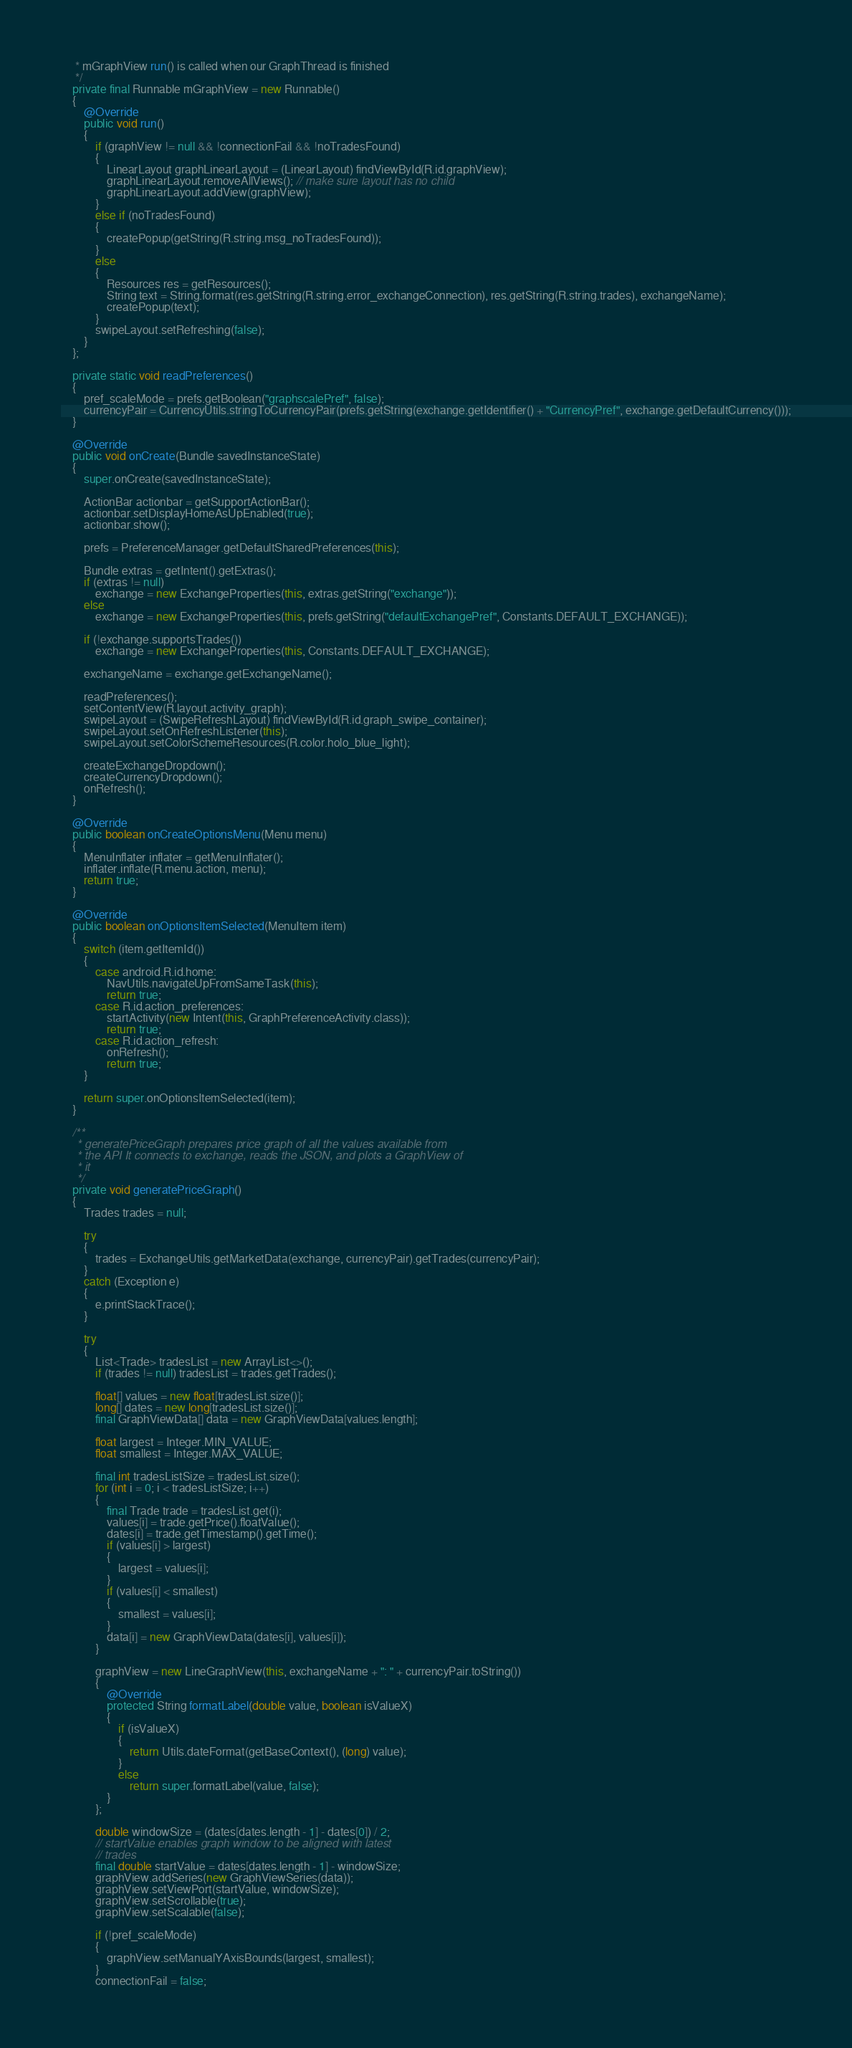<code> <loc_0><loc_0><loc_500><loc_500><_Java_>     * mGraphView run() is called when our GraphThread is finished
     */
    private final Runnable mGraphView = new Runnable()
    {
        @Override
        public void run()
        {
            if (graphView != null && !connectionFail && !noTradesFound)
            {
                LinearLayout graphLinearLayout = (LinearLayout) findViewById(R.id.graphView);
                graphLinearLayout.removeAllViews(); // make sure layout has no child
                graphLinearLayout.addView(graphView);
            }
            else if (noTradesFound)
            {
                createPopup(getString(R.string.msg_noTradesFound));
            }
            else
            {
                Resources res = getResources();
                String text = String.format(res.getString(R.string.error_exchangeConnection), res.getString(R.string.trades), exchangeName);
                createPopup(text);
            }
            swipeLayout.setRefreshing(false);
        }
    };

    private static void readPreferences()
    {
        pref_scaleMode = prefs.getBoolean("graphscalePref", false);
        currencyPair = CurrencyUtils.stringToCurrencyPair(prefs.getString(exchange.getIdentifier() + "CurrencyPref", exchange.getDefaultCurrency()));
    }

    @Override
    public void onCreate(Bundle savedInstanceState)
    {
        super.onCreate(savedInstanceState);

        ActionBar actionbar = getSupportActionBar();
        actionbar.setDisplayHomeAsUpEnabled(true);
        actionbar.show();

        prefs = PreferenceManager.getDefaultSharedPreferences(this);

        Bundle extras = getIntent().getExtras();
        if (extras != null)
            exchange = new ExchangeProperties(this, extras.getString("exchange"));
        else
            exchange = new ExchangeProperties(this, prefs.getString("defaultExchangePref", Constants.DEFAULT_EXCHANGE));

        if (!exchange.supportsTrades())
            exchange = new ExchangeProperties(this, Constants.DEFAULT_EXCHANGE);

        exchangeName = exchange.getExchangeName();

        readPreferences();
        setContentView(R.layout.activity_graph);
        swipeLayout = (SwipeRefreshLayout) findViewById(R.id.graph_swipe_container);
        swipeLayout.setOnRefreshListener(this);
        swipeLayout.setColorSchemeResources(R.color.holo_blue_light);

        createExchangeDropdown();
        createCurrencyDropdown();
        onRefresh();
    }

    @Override
    public boolean onCreateOptionsMenu(Menu menu)
    {
        MenuInflater inflater = getMenuInflater();
        inflater.inflate(R.menu.action, menu);
        return true;
    }

    @Override
    public boolean onOptionsItemSelected(MenuItem item)
    {
        switch (item.getItemId())
        {
            case android.R.id.home:
                NavUtils.navigateUpFromSameTask(this);
                return true;
            case R.id.action_preferences:
                startActivity(new Intent(this, GraphPreferenceActivity.class));
                return true;
            case R.id.action_refresh:
                onRefresh();
                return true;
        }

        return super.onOptionsItemSelected(item);
    }

    /**
     * generatePriceGraph prepares price graph of all the values available from
     * the API It connects to exchange, reads the JSON, and plots a GraphView of
     * it
     */
    private void generatePriceGraph()
    {
        Trades trades = null;

        try
        {
            trades = ExchangeUtils.getMarketData(exchange, currencyPair).getTrades(currencyPair);
        }
        catch (Exception e)
        {
            e.printStackTrace();
        }

        try
        {
            List<Trade> tradesList = new ArrayList<>();
            if (trades != null) tradesList = trades.getTrades();

            float[] values = new float[tradesList.size()];
            long[] dates = new long[tradesList.size()];
            final GraphViewData[] data = new GraphViewData[values.length];

            float largest = Integer.MIN_VALUE;
            float smallest = Integer.MAX_VALUE;

            final int tradesListSize = tradesList.size();
            for (int i = 0; i < tradesListSize; i++)
            {
                final Trade trade = tradesList.get(i);
                values[i] = trade.getPrice().floatValue();
                dates[i] = trade.getTimestamp().getTime();
                if (values[i] > largest)
                {
                    largest = values[i];
                }
                if (values[i] < smallest)
                {
                    smallest = values[i];
                }
                data[i] = new GraphViewData(dates[i], values[i]);
            }

            graphView = new LineGraphView(this, exchangeName + ": " + currencyPair.toString())
            {
                @Override
                protected String formatLabel(double value, boolean isValueX)
                {
                    if (isValueX)
                    {
                        return Utils.dateFormat(getBaseContext(), (long) value);
                    }
                    else
                        return super.formatLabel(value, false);
                }
            };

            double windowSize = (dates[dates.length - 1] - dates[0]) / 2;
            // startValue enables graph window to be aligned with latest
            // trades
            final double startValue = dates[dates.length - 1] - windowSize;
            graphView.addSeries(new GraphViewSeries(data));
            graphView.setViewPort(startValue, windowSize);
            graphView.setScrollable(true);
            graphView.setScalable(false);

            if (!pref_scaleMode)
            {
                graphView.setManualYAxisBounds(largest, smallest);
            }
            connectionFail = false;</code> 